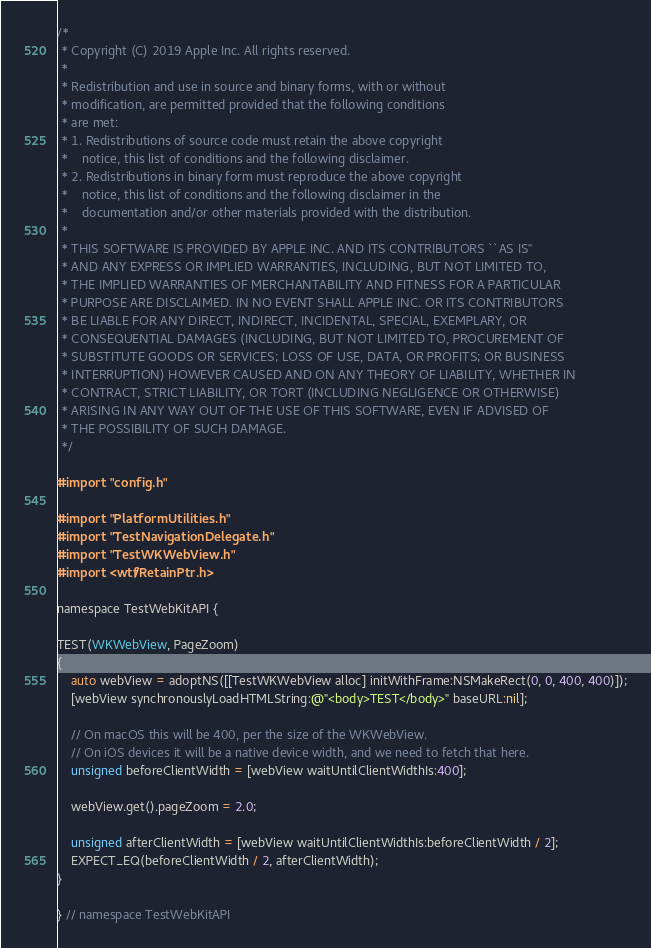Convert code to text. <code><loc_0><loc_0><loc_500><loc_500><_ObjectiveC_>/*
 * Copyright (C) 2019 Apple Inc. All rights reserved.
 *
 * Redistribution and use in source and binary forms, with or without
 * modification, are permitted provided that the following conditions
 * are met:
 * 1. Redistributions of source code must retain the above copyright
 *    notice, this list of conditions and the following disclaimer.
 * 2. Redistributions in binary form must reproduce the above copyright
 *    notice, this list of conditions and the following disclaimer in the
 *    documentation and/or other materials provided with the distribution.
 *
 * THIS SOFTWARE IS PROVIDED BY APPLE INC. AND ITS CONTRIBUTORS ``AS IS''
 * AND ANY EXPRESS OR IMPLIED WARRANTIES, INCLUDING, BUT NOT LIMITED TO,
 * THE IMPLIED WARRANTIES OF MERCHANTABILITY AND FITNESS FOR A PARTICULAR
 * PURPOSE ARE DISCLAIMED. IN NO EVENT SHALL APPLE INC. OR ITS CONTRIBUTORS
 * BE LIABLE FOR ANY DIRECT, INDIRECT, INCIDENTAL, SPECIAL, EXEMPLARY, OR
 * CONSEQUENTIAL DAMAGES (INCLUDING, BUT NOT LIMITED TO, PROCUREMENT OF
 * SUBSTITUTE GOODS OR SERVICES; LOSS OF USE, DATA, OR PROFITS; OR BUSINESS
 * INTERRUPTION) HOWEVER CAUSED AND ON ANY THEORY OF LIABILITY, WHETHER IN
 * CONTRACT, STRICT LIABILITY, OR TORT (INCLUDING NEGLIGENCE OR OTHERWISE)
 * ARISING IN ANY WAY OUT OF THE USE OF THIS SOFTWARE, EVEN IF ADVISED OF
 * THE POSSIBILITY OF SUCH DAMAGE.
 */

#import "config.h"

#import "PlatformUtilities.h"
#import "TestNavigationDelegate.h"
#import "TestWKWebView.h"
#import <wtf/RetainPtr.h>

namespace TestWebKitAPI {

TEST(WKWebView, PageZoom)
{
    auto webView = adoptNS([[TestWKWebView alloc] initWithFrame:NSMakeRect(0, 0, 400, 400)]);
    [webView synchronouslyLoadHTMLString:@"<body>TEST</body>" baseURL:nil];

    // On macOS this will be 400, per the size of the WKWebView.
    // On iOS devices it will be a native device width, and we need to fetch that here.
    unsigned beforeClientWidth = [webView waitUntilClientWidthIs:400];

    webView.get().pageZoom = 2.0;

    unsigned afterClientWidth = [webView waitUntilClientWidthIs:beforeClientWidth / 2];
    EXPECT_EQ(beforeClientWidth / 2, afterClientWidth);
}

} // namespace TestWebKitAPI
</code> 